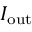Convert formula to latex. <formula><loc_0><loc_0><loc_500><loc_500>I _ { o u t }</formula> 